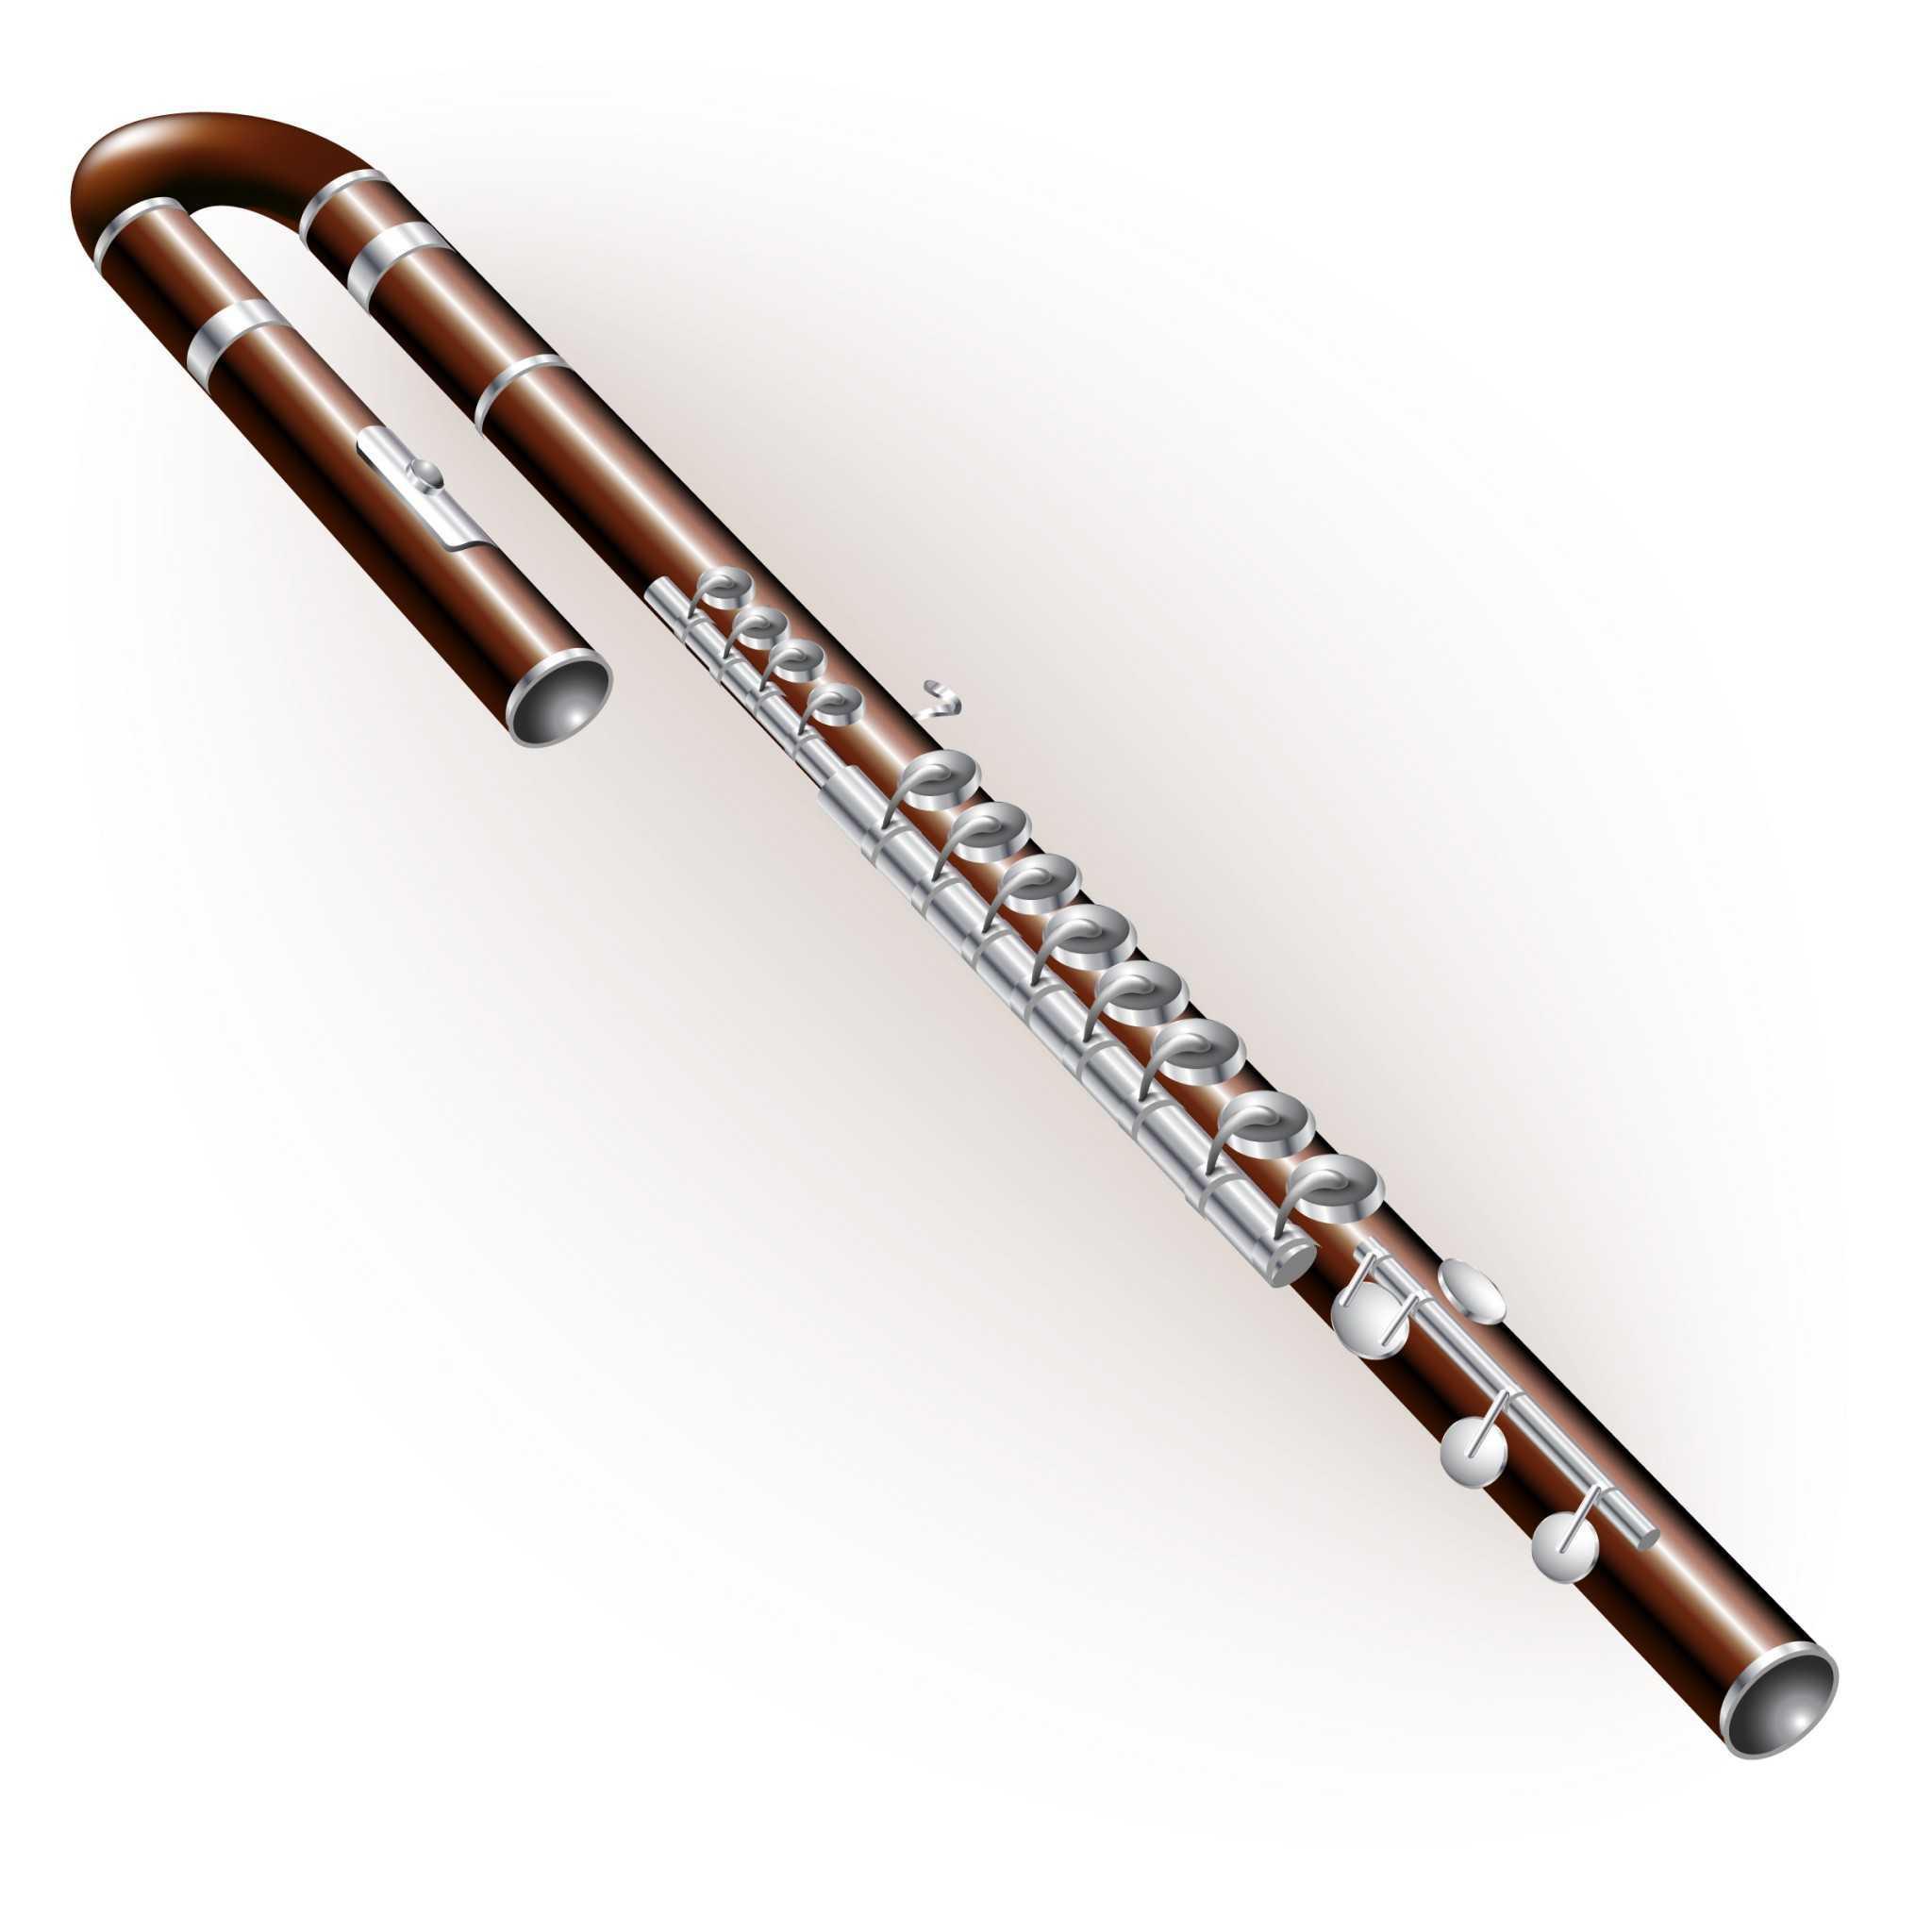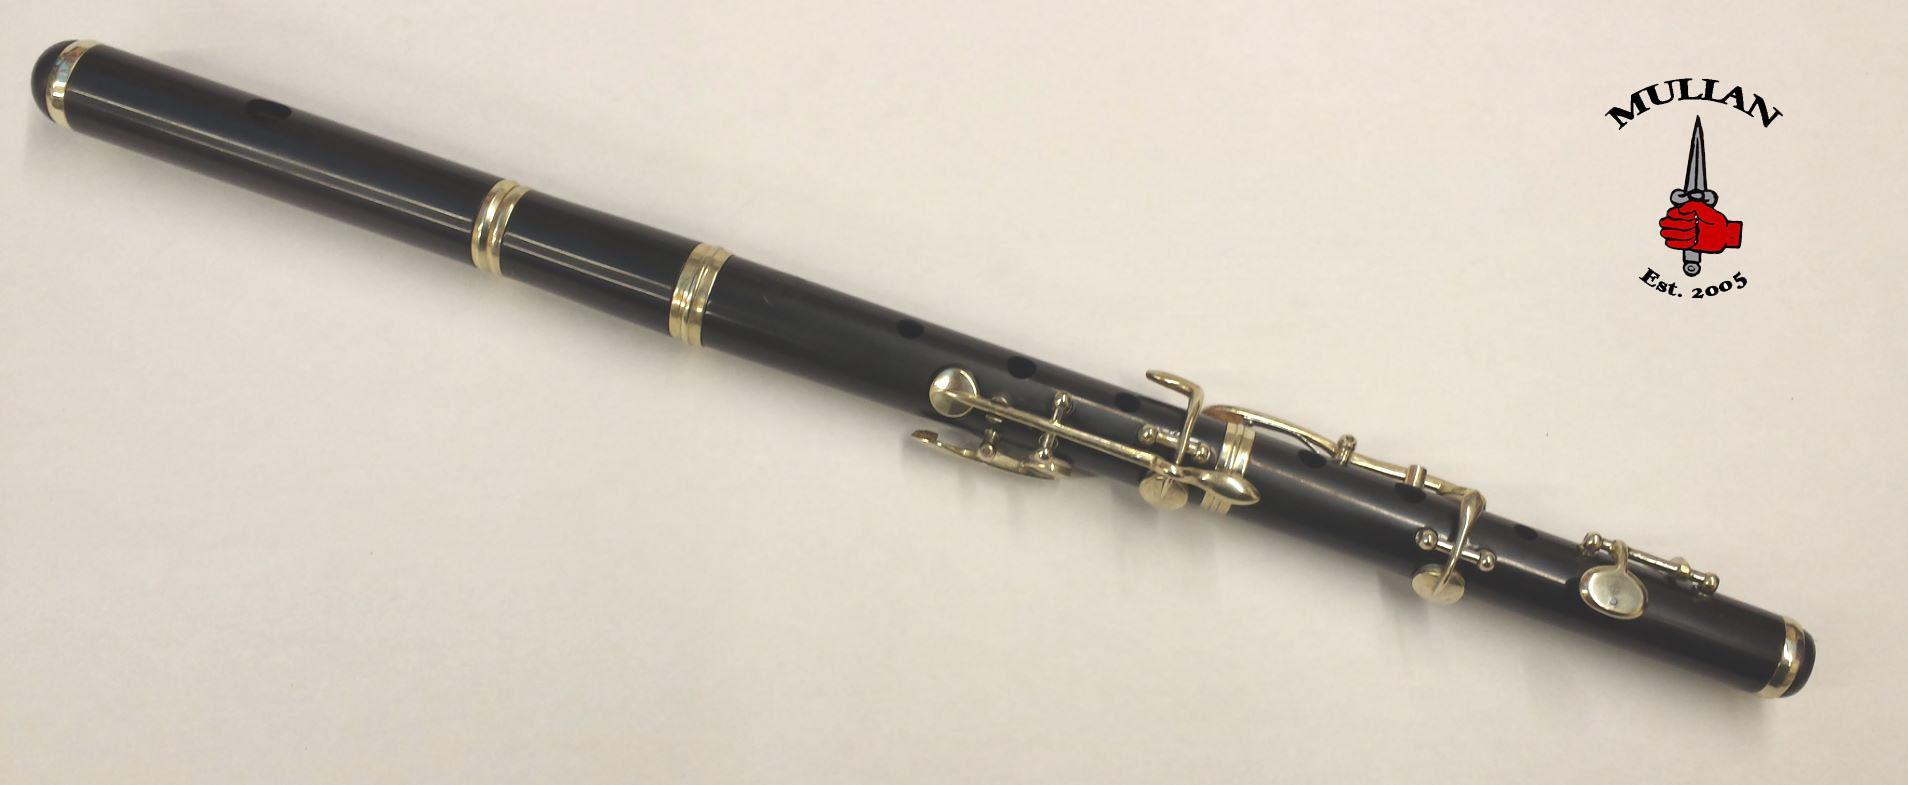The first image is the image on the left, the second image is the image on the right. Examine the images to the left and right. Is the description "There are two very dark colored flutes." accurate? Answer yes or no. Yes. The first image is the image on the left, the second image is the image on the right. For the images displayed, is the sentence "Each image contains exactly one dark flute with metal keys." factually correct? Answer yes or no. Yes. 